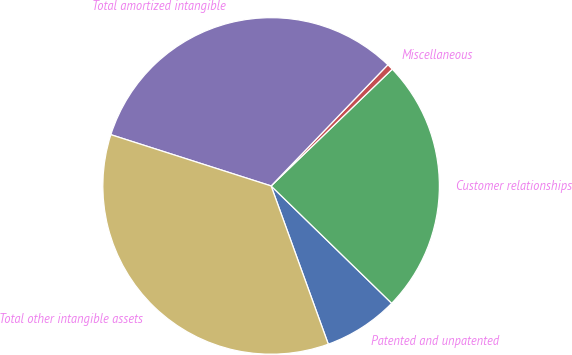Convert chart. <chart><loc_0><loc_0><loc_500><loc_500><pie_chart><fcel>Patented and unpatented<fcel>Customer relationships<fcel>Miscellaneous<fcel>Total amortized intangible<fcel>Total other intangible assets<nl><fcel>7.2%<fcel>24.49%<fcel>0.59%<fcel>32.28%<fcel>35.45%<nl></chart> 